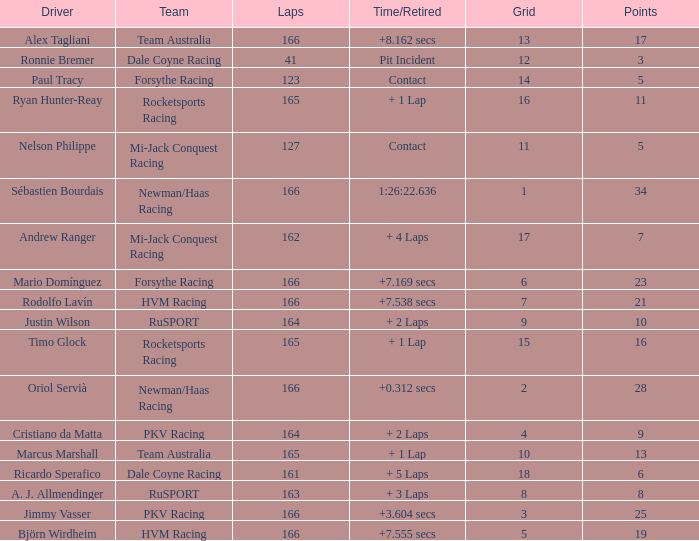What grid is the lowest when the time/retired is + 5 laps and the laps is less than 161? None. 